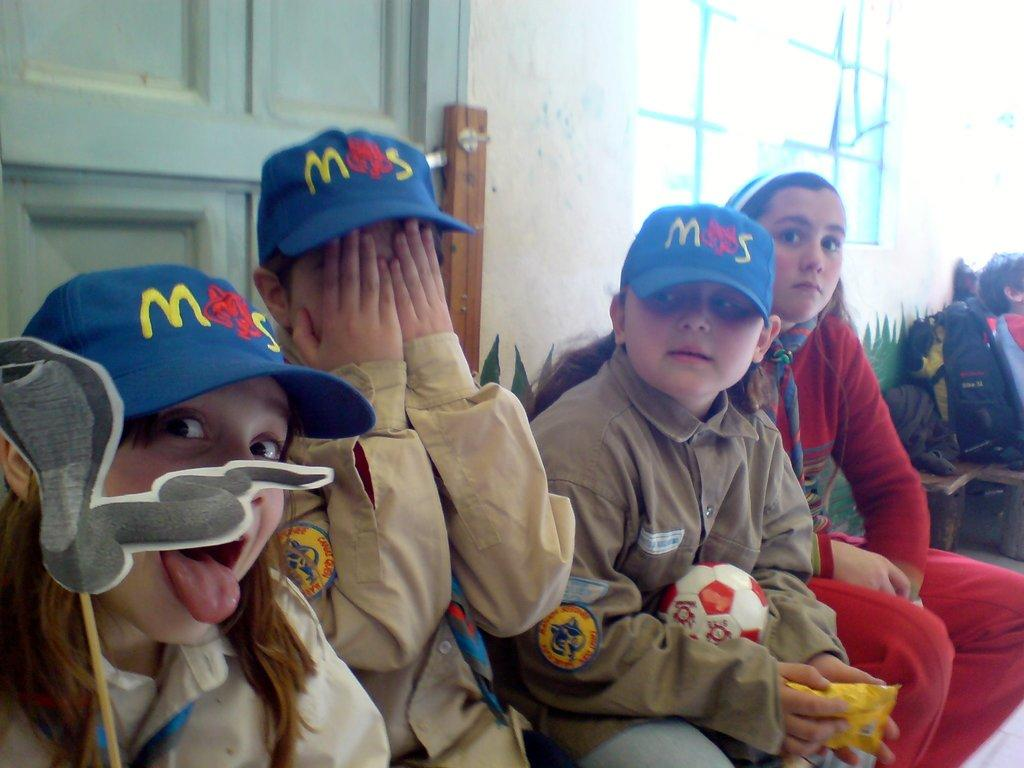What is the main subject of the image? The main subject of the image is a group of children. What are the children doing in the image? The children are sitting together and holding toys. What architectural features can be seen in the image? There is a door and a window in the image. Is the ground in the image made of quicksand? There is no indication of quicksand in the image; the children are sitting on a surface that appears to be solid. 